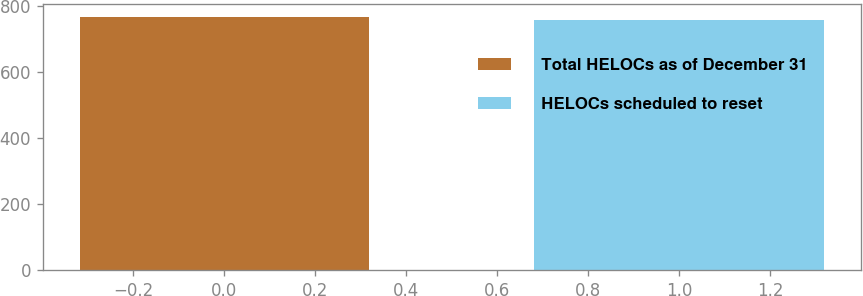<chart> <loc_0><loc_0><loc_500><loc_500><bar_chart><fcel>Total HELOCs as of December 31<fcel>HELOCs scheduled to reset<nl><fcel>766<fcel>758<nl></chart> 